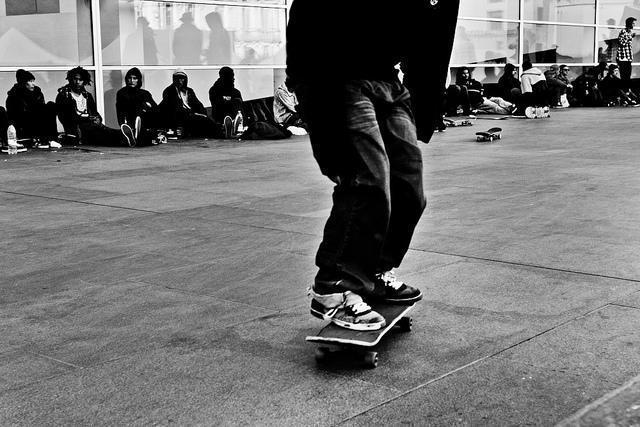How many people are in the photo?
Give a very brief answer. 5. How many dogs are in the picture?
Give a very brief answer. 0. 